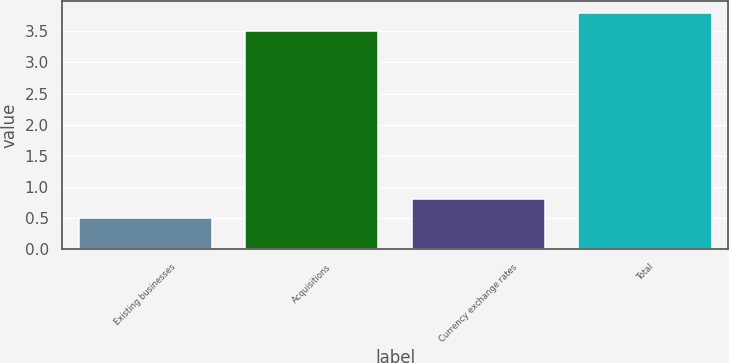Convert chart to OTSL. <chart><loc_0><loc_0><loc_500><loc_500><bar_chart><fcel>Existing businesses<fcel>Acquisitions<fcel>Currency exchange rates<fcel>Total<nl><fcel>0.5<fcel>3.5<fcel>0.8<fcel>3.8<nl></chart> 